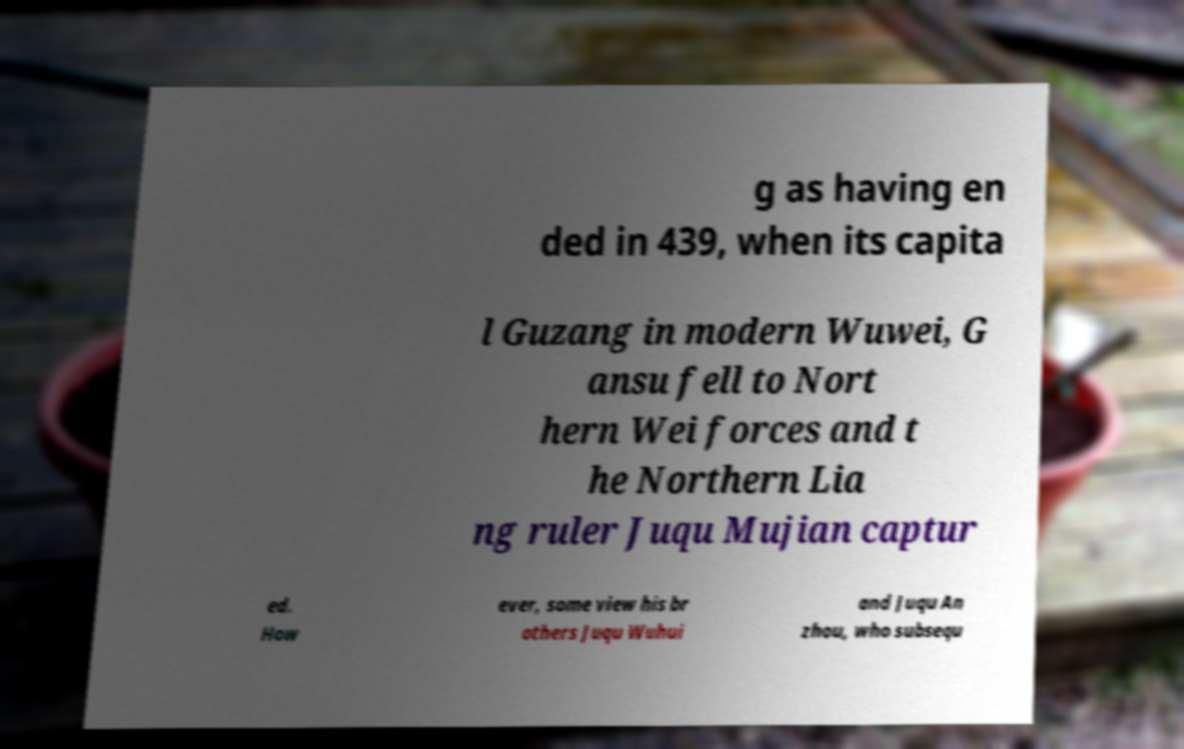Could you extract and type out the text from this image? g as having en ded in 439, when its capita l Guzang in modern Wuwei, G ansu fell to Nort hern Wei forces and t he Northern Lia ng ruler Juqu Mujian captur ed. How ever, some view his br others Juqu Wuhui and Juqu An zhou, who subsequ 